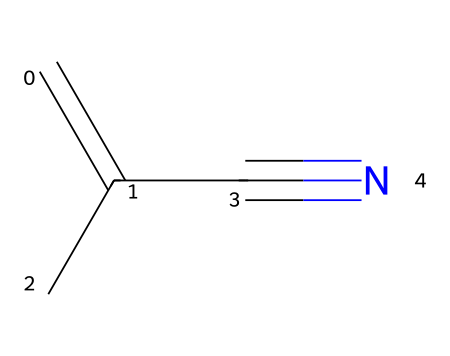What is the molecular formula of methacrylonitrile? The SMILES notation (C=C(C)C#N) can be decoded to find the molecular formula. It contains 5 carbon atoms, 7 hydrogen atoms, and 1 nitrogen atom, leading to the formula C5H7N.
Answer: C5H7N How many carbon atoms are in methacrylonitrile? By analyzing the SMILES string, we can count the carbon atoms represented by the 'C' characters. There are 5 instances of 'C', indicating there are 5 carbon atoms.
Answer: 5 What type of bond connects the carbon and nitrogen in methacrylonitrile? The SMILES representation shows a triple bond between the carbon and nitrogen, denoted by the '#'. This indicates that the bond is a triple bond.
Answer: triple bond What is the degree of unsaturation in methacrylonitrile? The structure contains one double bond (between C=C) and a triple bond (C#N), contributing to the degree of unsaturation. Each type of bond counts as one degree of unsaturation; thus, the total is 2.
Answer: 2 Which functional group is present in methacrylonitrile? The presence of the cyano group (-C#N) in the structure indicates that this compound contains a nitrile functional group. This is identified by looking for the carbon-nitrogen triple bond.
Answer: nitrile What is the significance of the arrangement of atoms in methacrylonitrile? The arrangement reveals that methacrylonitrile has both vinyl (C=C) and nitrile groups, which contribute to its reactivity and application as a monomer in plastic and resin production.
Answer: reactivity and application 